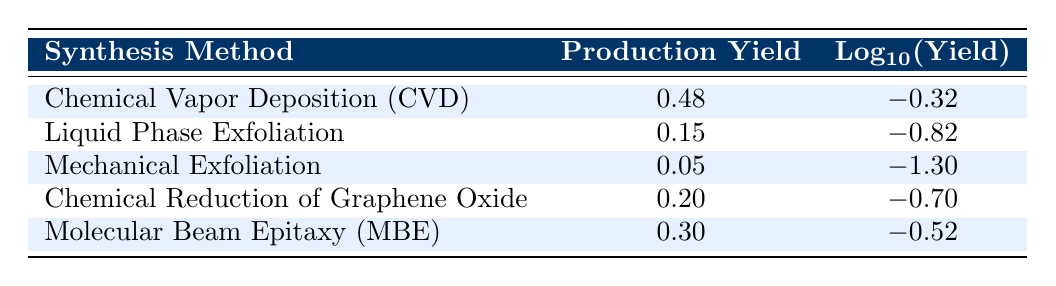What is the production yield for Chemical Vapor Deposition (CVD)? The table shows that the production yield for Chemical Vapor Deposition (CVD) is listed in the second column, which directly states the value as 0.48.
Answer: 0.48 Which synthesis method has the highest production yield? By comparing the production yields presented in the second column, Chemical Vapor Deposition (CVD) has the highest value at 0.48.
Answer: Chemical Vapor Deposition (CVD) What is the difference in production yield between Liquid Phase Exfoliation and Chemical Reduction of Graphene Oxide? The production yield for Liquid Phase Exfoliation is 0.15 and for Chemical Reduction of Graphene Oxide is 0.20. The difference is calculated as 0.20 - 0.15 = 0.05.
Answer: 0.05 Is the production yield for Mechanical Exfoliation greater than 0.10? The production yield for Mechanical Exfoliation is 0.05, which is less than 0.10. Therefore, the statement is false.
Answer: No What is the average production yield of all the synthesis methods listed? The production yields are 0.48, 0.15, 0.05, 0.20, and 0.30. First, sum these values: 0.48 + 0.15 + 0.05 + 0.20 + 0.30 = 1.18. Then, divide by the number of methods (5): 1.18 / 5 = 0.236.
Answer: 0.236 Which synthesis method has a production yield less than 0.10? Reviewing the table reveals that Mechanical Exfoliation has a production yield of 0.05, which is the only method listed with a yield less than 0.10.
Answer: Yes What is the logarithmic value of the production yield for Molecular Beam Epitaxy (MBE)? The table shows that the logarithmic value for Molecular Beam Epitaxy (MBE), under the third column, is listed as -0.52.
Answer: -0.52 If the production yield of Chemical Reduction of Graphene Oxide were to increase by 0.10, what would the new value be? The current yield for Chemical Reduction of Graphene Oxide is 0.20. If it increases by 0.10, the new yield would be 0.20 + 0.10 = 0.30.
Answer: 0.30 Is the production yield lower for Liquid Phase Exfoliation than for Mechanical Exfoliation? The production yield for Liquid Phase Exfoliation is 0.15, while for Mechanical Exfoliation it is 0.05. Since 0.15 is greater than 0.05, the statement is false.
Answer: No 